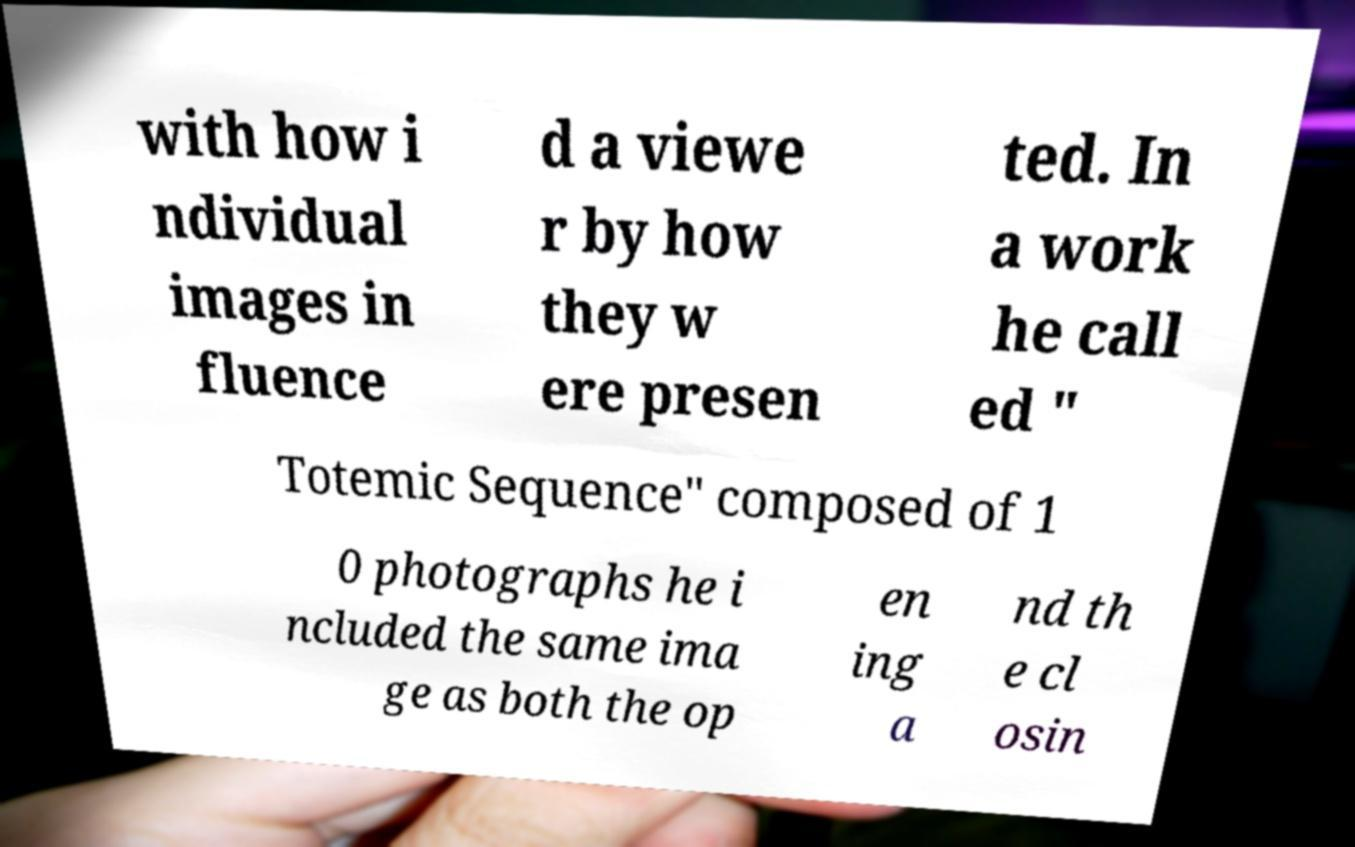Can you accurately transcribe the text from the provided image for me? with how i ndividual images in fluence d a viewe r by how they w ere presen ted. In a work he call ed " Totemic Sequence" composed of 1 0 photographs he i ncluded the same ima ge as both the op en ing a nd th e cl osin 